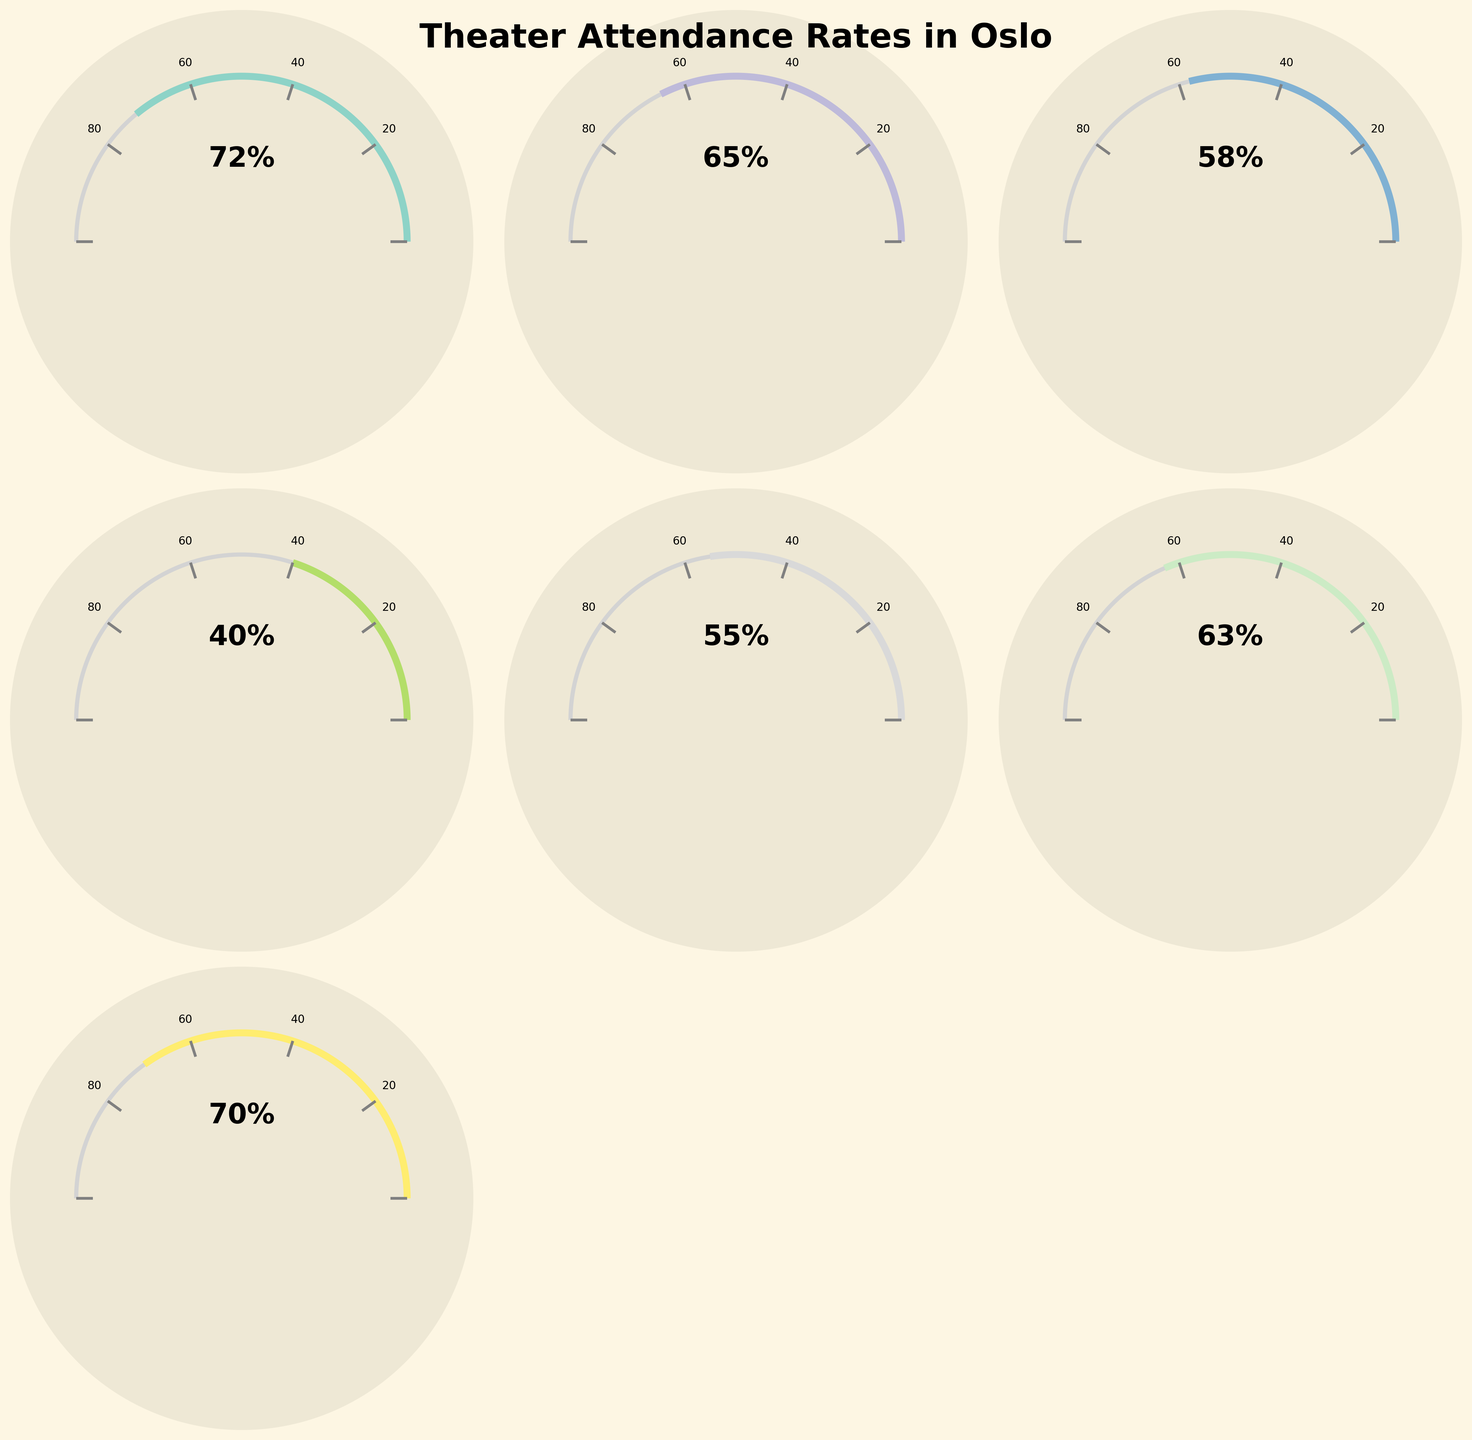Which genre has the highest attendance rate? The figure shows individual attendance rates for each genre. The genre with the highest rate will have the longest gauge. By comparing all gauges, Children's Theater has the highest percentage at 70%.
Answer: Children's Theater Which genre has the lowest attendance rate? By observing all gauges, the smallest gauge represents the lowest attendance rate. Experimental theater has an attendance rate of 40%, which is the lowest among all genres.
Answer: Experimental What is the average attendance rate across all genres? Sum the attendance rates of all genres and divide by the number of genres. (72 + 65 + 58 + 40 + 55 + 63 + 70) / 7 = 60.428.
Answer: 60.43 How many genres have an attendance rate above 60%? Count the number of genres with gauges extending beyond 60 percent. Drama (72%), Comedy (65%), Contemporary Norwegian (63%), Children's Theater (70%) make up four genres above 60%.
Answer: 4 Which genre attendance rate is closest to 50%? Identify the gauge closest to the 50% mark. Classical theater has an attendance rate of 55%, which is the closest to 50%.
Answer: Classical What's the difference in attendance rate between Drama and Musicals? Subtract the attendance rate of Musicals from Drama. 72% (Drama) - 58% (Musicals) = 14%.
Answer: 14% Is the attendance rate for Comedy greater than Contemporary Norwegian? Compare the gauges of Comedy and Contemporary Norwegian. Comedy is at 65%, while Contemporary Norwegian is at 63%.
Answer: Yes Which genre has the largest attendance rate difference compared to Children's Theater? Calculate the difference between Children's Theater (70%) and all other genres, then find the largest difference. Drama (72%), Comedy (65%), Musical (58%), Experimental (40%), Classical (55%), Contemporary Norwegian (63%), difference with Experimental = 70% - 40% = 30%, which is the largest difference.
Answer: Experimental Are there more genres with attendance rates above or below 60%? Count genres above 60% (Drama, Comedy, Contemporary Norwegian, Children's Theater) and below 60% (Musical, Experimental, Classical). Four genres are above, and three are below.
Answer: Above Which two genres have the most similar attendance rates? Find the smallest difference between any two genres. Contemporary Norwegian (63%) and Comedy (65%) have the smallest difference of 2%.
Answer: Comedy and Contemporary Norwegian 